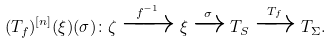Convert formula to latex. <formula><loc_0><loc_0><loc_500><loc_500>( T _ { f } ) ^ { [ n ] } ( \xi ) ( \sigma ) \colon \zeta \xrightarrow { f ^ { - 1 } } \xi \xrightarrow { \sigma } T _ { S } \xrightarrow { T _ { f } } T _ { \Sigma } .</formula> 